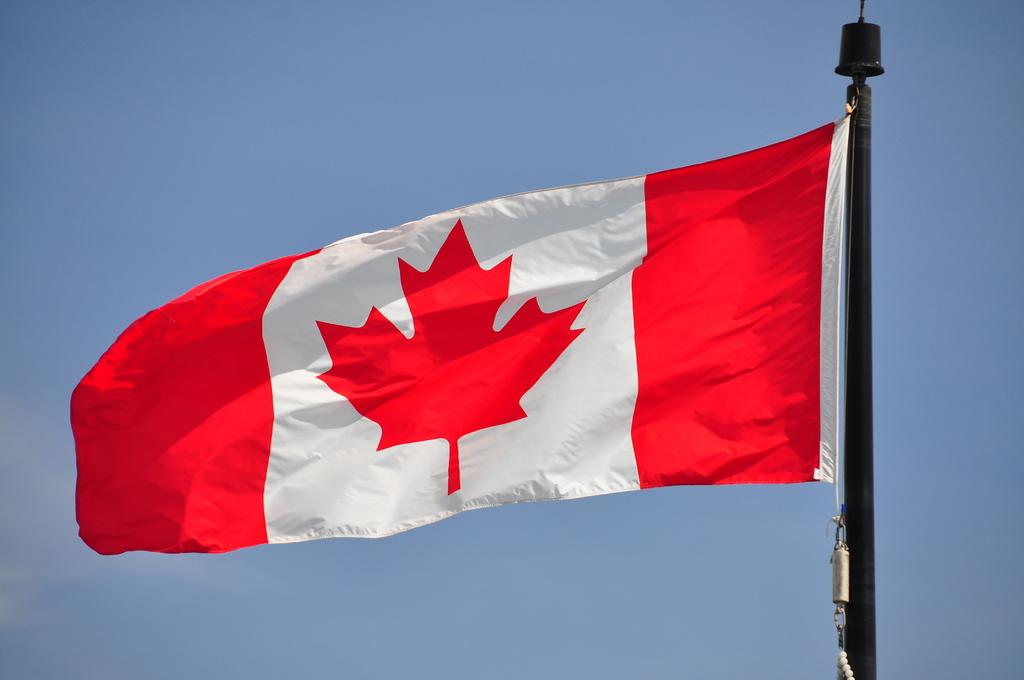What is present in the image that represents a country or organization? There is a flag in the image. How is the flag positioned in the image? The flag is flying in the air. What is the flag attached to in the image? The flag is attached to a pole. What type of learning material can be seen in the image? There is no learning material present in the image; it only features a flag flying in the air and attached to a pole. 